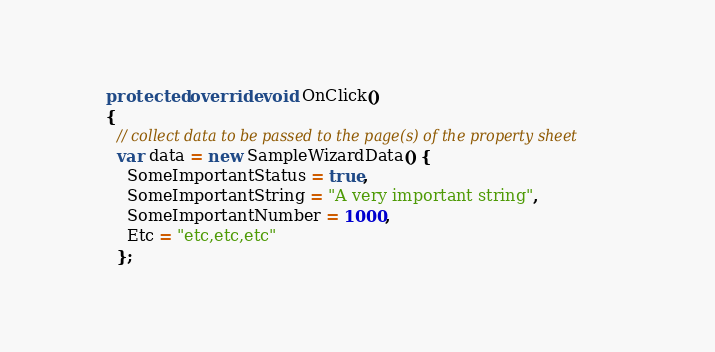Convert code to text. <code><loc_0><loc_0><loc_500><loc_500><_C#_>    protected override void OnClick()
    {
      // collect data to be passed to the page(s) of the property sheet
      var data = new SampleWizardData() {
        SomeImportantStatus = true,
        SomeImportantString = "A very important string",
        SomeImportantNumber = 1000,
        Etc = "etc,etc,etc"
      };</code> 